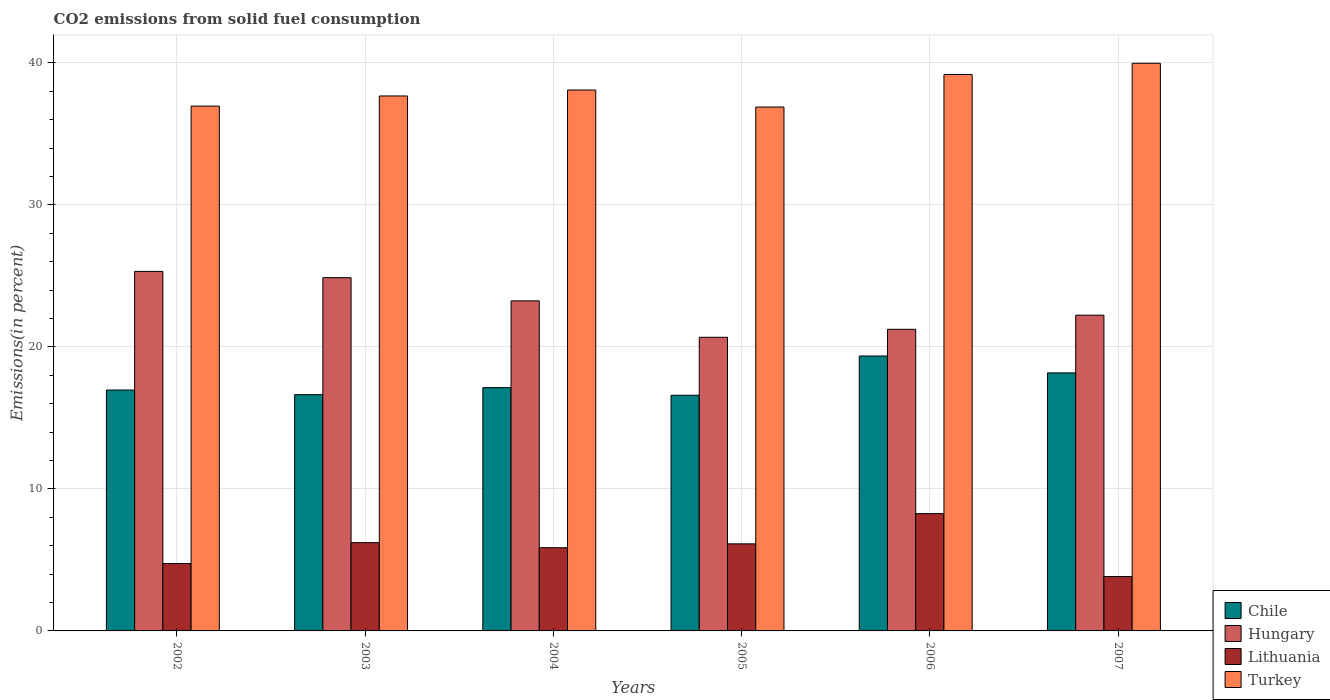How many different coloured bars are there?
Offer a very short reply. 4. Are the number of bars on each tick of the X-axis equal?
Offer a terse response. Yes. How many bars are there on the 3rd tick from the right?
Offer a terse response. 4. What is the label of the 2nd group of bars from the left?
Give a very brief answer. 2003. What is the total CO2 emitted in Lithuania in 2007?
Your response must be concise. 3.83. Across all years, what is the maximum total CO2 emitted in Chile?
Your response must be concise. 19.36. Across all years, what is the minimum total CO2 emitted in Turkey?
Your answer should be very brief. 36.9. In which year was the total CO2 emitted in Chile maximum?
Provide a short and direct response. 2006. What is the total total CO2 emitted in Lithuania in the graph?
Make the answer very short. 35.05. What is the difference between the total CO2 emitted in Turkey in 2003 and that in 2007?
Offer a terse response. -2.3. What is the difference between the total CO2 emitted in Lithuania in 2005 and the total CO2 emitted in Hungary in 2006?
Ensure brevity in your answer.  -15.11. What is the average total CO2 emitted in Hungary per year?
Give a very brief answer. 22.93. In the year 2003, what is the difference between the total CO2 emitted in Lithuania and total CO2 emitted in Turkey?
Keep it short and to the point. -31.46. In how many years, is the total CO2 emitted in Lithuania greater than 38 %?
Your answer should be compact. 0. What is the ratio of the total CO2 emitted in Lithuania in 2003 to that in 2004?
Offer a very short reply. 1.06. Is the difference between the total CO2 emitted in Lithuania in 2003 and 2007 greater than the difference between the total CO2 emitted in Turkey in 2003 and 2007?
Your answer should be very brief. Yes. What is the difference between the highest and the second highest total CO2 emitted in Turkey?
Offer a very short reply. 0.79. What is the difference between the highest and the lowest total CO2 emitted in Turkey?
Your answer should be compact. 3.08. What does the 2nd bar from the left in 2005 represents?
Ensure brevity in your answer.  Hungary. Are all the bars in the graph horizontal?
Ensure brevity in your answer.  No. How many years are there in the graph?
Your answer should be compact. 6. Are the values on the major ticks of Y-axis written in scientific E-notation?
Give a very brief answer. No. Does the graph contain grids?
Ensure brevity in your answer.  Yes. Where does the legend appear in the graph?
Your response must be concise. Bottom right. How are the legend labels stacked?
Provide a succinct answer. Vertical. What is the title of the graph?
Your answer should be very brief. CO2 emissions from solid fuel consumption. What is the label or title of the X-axis?
Keep it short and to the point. Years. What is the label or title of the Y-axis?
Offer a terse response. Emissions(in percent). What is the Emissions(in percent) of Chile in 2002?
Offer a very short reply. 16.96. What is the Emissions(in percent) in Hungary in 2002?
Keep it short and to the point. 25.32. What is the Emissions(in percent) of Lithuania in 2002?
Make the answer very short. 4.75. What is the Emissions(in percent) of Turkey in 2002?
Ensure brevity in your answer.  36.96. What is the Emissions(in percent) of Chile in 2003?
Give a very brief answer. 16.64. What is the Emissions(in percent) in Hungary in 2003?
Your answer should be compact. 24.88. What is the Emissions(in percent) of Lithuania in 2003?
Provide a succinct answer. 6.22. What is the Emissions(in percent) in Turkey in 2003?
Keep it short and to the point. 37.67. What is the Emissions(in percent) in Chile in 2004?
Offer a terse response. 17.13. What is the Emissions(in percent) of Hungary in 2004?
Ensure brevity in your answer.  23.24. What is the Emissions(in percent) in Lithuania in 2004?
Offer a terse response. 5.86. What is the Emissions(in percent) in Turkey in 2004?
Give a very brief answer. 38.09. What is the Emissions(in percent) of Chile in 2005?
Your response must be concise. 16.6. What is the Emissions(in percent) of Hungary in 2005?
Give a very brief answer. 20.68. What is the Emissions(in percent) of Lithuania in 2005?
Ensure brevity in your answer.  6.13. What is the Emissions(in percent) of Turkey in 2005?
Ensure brevity in your answer.  36.9. What is the Emissions(in percent) of Chile in 2006?
Provide a short and direct response. 19.36. What is the Emissions(in percent) of Hungary in 2006?
Your answer should be compact. 21.24. What is the Emissions(in percent) of Lithuania in 2006?
Provide a short and direct response. 8.26. What is the Emissions(in percent) of Turkey in 2006?
Your response must be concise. 39.19. What is the Emissions(in percent) of Chile in 2007?
Your answer should be very brief. 18.17. What is the Emissions(in percent) of Hungary in 2007?
Provide a succinct answer. 22.24. What is the Emissions(in percent) in Lithuania in 2007?
Offer a very short reply. 3.83. What is the Emissions(in percent) of Turkey in 2007?
Make the answer very short. 39.98. Across all years, what is the maximum Emissions(in percent) in Chile?
Your answer should be compact. 19.36. Across all years, what is the maximum Emissions(in percent) in Hungary?
Your answer should be very brief. 25.32. Across all years, what is the maximum Emissions(in percent) of Lithuania?
Your answer should be very brief. 8.26. Across all years, what is the maximum Emissions(in percent) of Turkey?
Give a very brief answer. 39.98. Across all years, what is the minimum Emissions(in percent) in Chile?
Offer a terse response. 16.6. Across all years, what is the minimum Emissions(in percent) of Hungary?
Make the answer very short. 20.68. Across all years, what is the minimum Emissions(in percent) of Lithuania?
Your answer should be very brief. 3.83. Across all years, what is the minimum Emissions(in percent) of Turkey?
Your answer should be very brief. 36.9. What is the total Emissions(in percent) in Chile in the graph?
Make the answer very short. 104.87. What is the total Emissions(in percent) in Hungary in the graph?
Give a very brief answer. 137.6. What is the total Emissions(in percent) of Lithuania in the graph?
Provide a succinct answer. 35.05. What is the total Emissions(in percent) in Turkey in the graph?
Your response must be concise. 228.79. What is the difference between the Emissions(in percent) in Chile in 2002 and that in 2003?
Your response must be concise. 0.33. What is the difference between the Emissions(in percent) in Hungary in 2002 and that in 2003?
Make the answer very short. 0.44. What is the difference between the Emissions(in percent) of Lithuania in 2002 and that in 2003?
Your response must be concise. -1.47. What is the difference between the Emissions(in percent) of Turkey in 2002 and that in 2003?
Provide a short and direct response. -0.71. What is the difference between the Emissions(in percent) in Chile in 2002 and that in 2004?
Give a very brief answer. -0.17. What is the difference between the Emissions(in percent) in Hungary in 2002 and that in 2004?
Give a very brief answer. 2.08. What is the difference between the Emissions(in percent) in Lithuania in 2002 and that in 2004?
Give a very brief answer. -1.11. What is the difference between the Emissions(in percent) of Turkey in 2002 and that in 2004?
Ensure brevity in your answer.  -1.13. What is the difference between the Emissions(in percent) in Chile in 2002 and that in 2005?
Your answer should be very brief. 0.37. What is the difference between the Emissions(in percent) of Hungary in 2002 and that in 2005?
Make the answer very short. 4.64. What is the difference between the Emissions(in percent) of Lithuania in 2002 and that in 2005?
Give a very brief answer. -1.39. What is the difference between the Emissions(in percent) in Turkey in 2002 and that in 2005?
Keep it short and to the point. 0.07. What is the difference between the Emissions(in percent) in Chile in 2002 and that in 2006?
Keep it short and to the point. -2.4. What is the difference between the Emissions(in percent) in Hungary in 2002 and that in 2006?
Your answer should be compact. 4.08. What is the difference between the Emissions(in percent) of Lithuania in 2002 and that in 2006?
Keep it short and to the point. -3.51. What is the difference between the Emissions(in percent) of Turkey in 2002 and that in 2006?
Offer a terse response. -2.23. What is the difference between the Emissions(in percent) of Chile in 2002 and that in 2007?
Provide a short and direct response. -1.21. What is the difference between the Emissions(in percent) in Hungary in 2002 and that in 2007?
Your response must be concise. 3.08. What is the difference between the Emissions(in percent) in Lithuania in 2002 and that in 2007?
Keep it short and to the point. 0.92. What is the difference between the Emissions(in percent) of Turkey in 2002 and that in 2007?
Ensure brevity in your answer.  -3.02. What is the difference between the Emissions(in percent) of Chile in 2003 and that in 2004?
Ensure brevity in your answer.  -0.49. What is the difference between the Emissions(in percent) of Hungary in 2003 and that in 2004?
Offer a very short reply. 1.63. What is the difference between the Emissions(in percent) in Lithuania in 2003 and that in 2004?
Your answer should be compact. 0.36. What is the difference between the Emissions(in percent) of Turkey in 2003 and that in 2004?
Give a very brief answer. -0.42. What is the difference between the Emissions(in percent) in Chile in 2003 and that in 2005?
Offer a very short reply. 0.04. What is the difference between the Emissions(in percent) of Hungary in 2003 and that in 2005?
Give a very brief answer. 4.2. What is the difference between the Emissions(in percent) in Lithuania in 2003 and that in 2005?
Make the answer very short. 0.09. What is the difference between the Emissions(in percent) in Turkey in 2003 and that in 2005?
Your response must be concise. 0.78. What is the difference between the Emissions(in percent) in Chile in 2003 and that in 2006?
Make the answer very short. -2.72. What is the difference between the Emissions(in percent) in Hungary in 2003 and that in 2006?
Provide a succinct answer. 3.64. What is the difference between the Emissions(in percent) in Lithuania in 2003 and that in 2006?
Give a very brief answer. -2.04. What is the difference between the Emissions(in percent) in Turkey in 2003 and that in 2006?
Your response must be concise. -1.51. What is the difference between the Emissions(in percent) in Chile in 2003 and that in 2007?
Offer a terse response. -1.53. What is the difference between the Emissions(in percent) in Hungary in 2003 and that in 2007?
Your answer should be compact. 2.64. What is the difference between the Emissions(in percent) in Lithuania in 2003 and that in 2007?
Make the answer very short. 2.39. What is the difference between the Emissions(in percent) in Turkey in 2003 and that in 2007?
Your response must be concise. -2.3. What is the difference between the Emissions(in percent) of Chile in 2004 and that in 2005?
Ensure brevity in your answer.  0.54. What is the difference between the Emissions(in percent) in Hungary in 2004 and that in 2005?
Provide a succinct answer. 2.56. What is the difference between the Emissions(in percent) in Lithuania in 2004 and that in 2005?
Your answer should be very brief. -0.27. What is the difference between the Emissions(in percent) in Turkey in 2004 and that in 2005?
Ensure brevity in your answer.  1.2. What is the difference between the Emissions(in percent) of Chile in 2004 and that in 2006?
Ensure brevity in your answer.  -2.23. What is the difference between the Emissions(in percent) in Hungary in 2004 and that in 2006?
Your answer should be very brief. 2. What is the difference between the Emissions(in percent) in Lithuania in 2004 and that in 2006?
Ensure brevity in your answer.  -2.4. What is the difference between the Emissions(in percent) in Turkey in 2004 and that in 2006?
Your answer should be very brief. -1.09. What is the difference between the Emissions(in percent) in Chile in 2004 and that in 2007?
Offer a very short reply. -1.04. What is the difference between the Emissions(in percent) in Hungary in 2004 and that in 2007?
Offer a very short reply. 1.01. What is the difference between the Emissions(in percent) in Lithuania in 2004 and that in 2007?
Offer a very short reply. 2.03. What is the difference between the Emissions(in percent) in Turkey in 2004 and that in 2007?
Your answer should be very brief. -1.88. What is the difference between the Emissions(in percent) of Chile in 2005 and that in 2006?
Keep it short and to the point. -2.76. What is the difference between the Emissions(in percent) of Hungary in 2005 and that in 2006?
Your answer should be compact. -0.56. What is the difference between the Emissions(in percent) of Lithuania in 2005 and that in 2006?
Your answer should be very brief. -2.13. What is the difference between the Emissions(in percent) in Turkey in 2005 and that in 2006?
Make the answer very short. -2.29. What is the difference between the Emissions(in percent) in Chile in 2005 and that in 2007?
Provide a short and direct response. -1.57. What is the difference between the Emissions(in percent) in Hungary in 2005 and that in 2007?
Offer a terse response. -1.56. What is the difference between the Emissions(in percent) of Lithuania in 2005 and that in 2007?
Your answer should be compact. 2.3. What is the difference between the Emissions(in percent) in Turkey in 2005 and that in 2007?
Your answer should be very brief. -3.08. What is the difference between the Emissions(in percent) of Chile in 2006 and that in 2007?
Keep it short and to the point. 1.19. What is the difference between the Emissions(in percent) of Hungary in 2006 and that in 2007?
Provide a succinct answer. -1. What is the difference between the Emissions(in percent) of Lithuania in 2006 and that in 2007?
Provide a succinct answer. 4.43. What is the difference between the Emissions(in percent) of Turkey in 2006 and that in 2007?
Your answer should be very brief. -0.79. What is the difference between the Emissions(in percent) of Chile in 2002 and the Emissions(in percent) of Hungary in 2003?
Provide a succinct answer. -7.91. What is the difference between the Emissions(in percent) of Chile in 2002 and the Emissions(in percent) of Lithuania in 2003?
Make the answer very short. 10.75. What is the difference between the Emissions(in percent) of Chile in 2002 and the Emissions(in percent) of Turkey in 2003?
Offer a very short reply. -20.71. What is the difference between the Emissions(in percent) of Hungary in 2002 and the Emissions(in percent) of Lithuania in 2003?
Keep it short and to the point. 19.1. What is the difference between the Emissions(in percent) of Hungary in 2002 and the Emissions(in percent) of Turkey in 2003?
Provide a short and direct response. -12.36. What is the difference between the Emissions(in percent) of Lithuania in 2002 and the Emissions(in percent) of Turkey in 2003?
Ensure brevity in your answer.  -32.93. What is the difference between the Emissions(in percent) of Chile in 2002 and the Emissions(in percent) of Hungary in 2004?
Provide a short and direct response. -6.28. What is the difference between the Emissions(in percent) of Chile in 2002 and the Emissions(in percent) of Lithuania in 2004?
Your answer should be compact. 11.11. What is the difference between the Emissions(in percent) of Chile in 2002 and the Emissions(in percent) of Turkey in 2004?
Your answer should be very brief. -21.13. What is the difference between the Emissions(in percent) in Hungary in 2002 and the Emissions(in percent) in Lithuania in 2004?
Provide a short and direct response. 19.46. What is the difference between the Emissions(in percent) in Hungary in 2002 and the Emissions(in percent) in Turkey in 2004?
Your answer should be compact. -12.77. What is the difference between the Emissions(in percent) of Lithuania in 2002 and the Emissions(in percent) of Turkey in 2004?
Offer a very short reply. -33.35. What is the difference between the Emissions(in percent) of Chile in 2002 and the Emissions(in percent) of Hungary in 2005?
Your response must be concise. -3.72. What is the difference between the Emissions(in percent) in Chile in 2002 and the Emissions(in percent) in Lithuania in 2005?
Provide a short and direct response. 10.83. What is the difference between the Emissions(in percent) in Chile in 2002 and the Emissions(in percent) in Turkey in 2005?
Offer a very short reply. -19.93. What is the difference between the Emissions(in percent) of Hungary in 2002 and the Emissions(in percent) of Lithuania in 2005?
Your answer should be very brief. 19.19. What is the difference between the Emissions(in percent) in Hungary in 2002 and the Emissions(in percent) in Turkey in 2005?
Give a very brief answer. -11.58. What is the difference between the Emissions(in percent) in Lithuania in 2002 and the Emissions(in percent) in Turkey in 2005?
Your answer should be very brief. -32.15. What is the difference between the Emissions(in percent) of Chile in 2002 and the Emissions(in percent) of Hungary in 2006?
Ensure brevity in your answer.  -4.27. What is the difference between the Emissions(in percent) in Chile in 2002 and the Emissions(in percent) in Lithuania in 2006?
Provide a succinct answer. 8.7. What is the difference between the Emissions(in percent) in Chile in 2002 and the Emissions(in percent) in Turkey in 2006?
Your answer should be very brief. -22.22. What is the difference between the Emissions(in percent) in Hungary in 2002 and the Emissions(in percent) in Lithuania in 2006?
Offer a very short reply. 17.06. What is the difference between the Emissions(in percent) of Hungary in 2002 and the Emissions(in percent) of Turkey in 2006?
Offer a very short reply. -13.87. What is the difference between the Emissions(in percent) of Lithuania in 2002 and the Emissions(in percent) of Turkey in 2006?
Make the answer very short. -34.44. What is the difference between the Emissions(in percent) in Chile in 2002 and the Emissions(in percent) in Hungary in 2007?
Provide a short and direct response. -5.27. What is the difference between the Emissions(in percent) in Chile in 2002 and the Emissions(in percent) in Lithuania in 2007?
Offer a terse response. 13.14. What is the difference between the Emissions(in percent) in Chile in 2002 and the Emissions(in percent) in Turkey in 2007?
Your answer should be very brief. -23.01. What is the difference between the Emissions(in percent) in Hungary in 2002 and the Emissions(in percent) in Lithuania in 2007?
Ensure brevity in your answer.  21.49. What is the difference between the Emissions(in percent) in Hungary in 2002 and the Emissions(in percent) in Turkey in 2007?
Provide a succinct answer. -14.66. What is the difference between the Emissions(in percent) in Lithuania in 2002 and the Emissions(in percent) in Turkey in 2007?
Provide a succinct answer. -35.23. What is the difference between the Emissions(in percent) of Chile in 2003 and the Emissions(in percent) of Hungary in 2004?
Provide a succinct answer. -6.6. What is the difference between the Emissions(in percent) in Chile in 2003 and the Emissions(in percent) in Lithuania in 2004?
Provide a short and direct response. 10.78. What is the difference between the Emissions(in percent) in Chile in 2003 and the Emissions(in percent) in Turkey in 2004?
Provide a succinct answer. -21.45. What is the difference between the Emissions(in percent) of Hungary in 2003 and the Emissions(in percent) of Lithuania in 2004?
Make the answer very short. 19.02. What is the difference between the Emissions(in percent) of Hungary in 2003 and the Emissions(in percent) of Turkey in 2004?
Make the answer very short. -13.22. What is the difference between the Emissions(in percent) of Lithuania in 2003 and the Emissions(in percent) of Turkey in 2004?
Keep it short and to the point. -31.88. What is the difference between the Emissions(in percent) in Chile in 2003 and the Emissions(in percent) in Hungary in 2005?
Make the answer very short. -4.04. What is the difference between the Emissions(in percent) of Chile in 2003 and the Emissions(in percent) of Lithuania in 2005?
Your response must be concise. 10.51. What is the difference between the Emissions(in percent) of Chile in 2003 and the Emissions(in percent) of Turkey in 2005?
Offer a terse response. -20.26. What is the difference between the Emissions(in percent) in Hungary in 2003 and the Emissions(in percent) in Lithuania in 2005?
Offer a very short reply. 18.75. What is the difference between the Emissions(in percent) in Hungary in 2003 and the Emissions(in percent) in Turkey in 2005?
Your answer should be compact. -12.02. What is the difference between the Emissions(in percent) in Lithuania in 2003 and the Emissions(in percent) in Turkey in 2005?
Give a very brief answer. -30.68. What is the difference between the Emissions(in percent) in Chile in 2003 and the Emissions(in percent) in Hungary in 2006?
Give a very brief answer. -4.6. What is the difference between the Emissions(in percent) in Chile in 2003 and the Emissions(in percent) in Lithuania in 2006?
Give a very brief answer. 8.38. What is the difference between the Emissions(in percent) in Chile in 2003 and the Emissions(in percent) in Turkey in 2006?
Ensure brevity in your answer.  -22.55. What is the difference between the Emissions(in percent) of Hungary in 2003 and the Emissions(in percent) of Lithuania in 2006?
Provide a succinct answer. 16.62. What is the difference between the Emissions(in percent) in Hungary in 2003 and the Emissions(in percent) in Turkey in 2006?
Your answer should be very brief. -14.31. What is the difference between the Emissions(in percent) of Lithuania in 2003 and the Emissions(in percent) of Turkey in 2006?
Your answer should be very brief. -32.97. What is the difference between the Emissions(in percent) in Chile in 2003 and the Emissions(in percent) in Hungary in 2007?
Offer a very short reply. -5.6. What is the difference between the Emissions(in percent) of Chile in 2003 and the Emissions(in percent) of Lithuania in 2007?
Provide a succinct answer. 12.81. What is the difference between the Emissions(in percent) in Chile in 2003 and the Emissions(in percent) in Turkey in 2007?
Offer a terse response. -23.34. What is the difference between the Emissions(in percent) in Hungary in 2003 and the Emissions(in percent) in Lithuania in 2007?
Keep it short and to the point. 21.05. What is the difference between the Emissions(in percent) of Hungary in 2003 and the Emissions(in percent) of Turkey in 2007?
Ensure brevity in your answer.  -15.1. What is the difference between the Emissions(in percent) in Lithuania in 2003 and the Emissions(in percent) in Turkey in 2007?
Your answer should be compact. -33.76. What is the difference between the Emissions(in percent) of Chile in 2004 and the Emissions(in percent) of Hungary in 2005?
Give a very brief answer. -3.55. What is the difference between the Emissions(in percent) in Chile in 2004 and the Emissions(in percent) in Lithuania in 2005?
Offer a very short reply. 11. What is the difference between the Emissions(in percent) of Chile in 2004 and the Emissions(in percent) of Turkey in 2005?
Keep it short and to the point. -19.76. What is the difference between the Emissions(in percent) in Hungary in 2004 and the Emissions(in percent) in Lithuania in 2005?
Offer a very short reply. 17.11. What is the difference between the Emissions(in percent) of Hungary in 2004 and the Emissions(in percent) of Turkey in 2005?
Make the answer very short. -13.65. What is the difference between the Emissions(in percent) in Lithuania in 2004 and the Emissions(in percent) in Turkey in 2005?
Ensure brevity in your answer.  -31.04. What is the difference between the Emissions(in percent) in Chile in 2004 and the Emissions(in percent) in Hungary in 2006?
Your response must be concise. -4.11. What is the difference between the Emissions(in percent) in Chile in 2004 and the Emissions(in percent) in Lithuania in 2006?
Your response must be concise. 8.87. What is the difference between the Emissions(in percent) of Chile in 2004 and the Emissions(in percent) of Turkey in 2006?
Give a very brief answer. -22.05. What is the difference between the Emissions(in percent) of Hungary in 2004 and the Emissions(in percent) of Lithuania in 2006?
Keep it short and to the point. 14.98. What is the difference between the Emissions(in percent) of Hungary in 2004 and the Emissions(in percent) of Turkey in 2006?
Make the answer very short. -15.94. What is the difference between the Emissions(in percent) of Lithuania in 2004 and the Emissions(in percent) of Turkey in 2006?
Your response must be concise. -33.33. What is the difference between the Emissions(in percent) in Chile in 2004 and the Emissions(in percent) in Hungary in 2007?
Offer a terse response. -5.1. What is the difference between the Emissions(in percent) in Chile in 2004 and the Emissions(in percent) in Lithuania in 2007?
Keep it short and to the point. 13.3. What is the difference between the Emissions(in percent) of Chile in 2004 and the Emissions(in percent) of Turkey in 2007?
Make the answer very short. -22.84. What is the difference between the Emissions(in percent) of Hungary in 2004 and the Emissions(in percent) of Lithuania in 2007?
Your answer should be compact. 19.41. What is the difference between the Emissions(in percent) in Hungary in 2004 and the Emissions(in percent) in Turkey in 2007?
Ensure brevity in your answer.  -16.73. What is the difference between the Emissions(in percent) of Lithuania in 2004 and the Emissions(in percent) of Turkey in 2007?
Your answer should be very brief. -34.12. What is the difference between the Emissions(in percent) of Chile in 2005 and the Emissions(in percent) of Hungary in 2006?
Give a very brief answer. -4.64. What is the difference between the Emissions(in percent) of Chile in 2005 and the Emissions(in percent) of Lithuania in 2006?
Offer a very short reply. 8.34. What is the difference between the Emissions(in percent) in Chile in 2005 and the Emissions(in percent) in Turkey in 2006?
Your answer should be very brief. -22.59. What is the difference between the Emissions(in percent) in Hungary in 2005 and the Emissions(in percent) in Lithuania in 2006?
Make the answer very short. 12.42. What is the difference between the Emissions(in percent) in Hungary in 2005 and the Emissions(in percent) in Turkey in 2006?
Keep it short and to the point. -18.51. What is the difference between the Emissions(in percent) of Lithuania in 2005 and the Emissions(in percent) of Turkey in 2006?
Offer a terse response. -33.05. What is the difference between the Emissions(in percent) of Chile in 2005 and the Emissions(in percent) of Hungary in 2007?
Offer a very short reply. -5.64. What is the difference between the Emissions(in percent) in Chile in 2005 and the Emissions(in percent) in Lithuania in 2007?
Keep it short and to the point. 12.77. What is the difference between the Emissions(in percent) of Chile in 2005 and the Emissions(in percent) of Turkey in 2007?
Offer a terse response. -23.38. What is the difference between the Emissions(in percent) of Hungary in 2005 and the Emissions(in percent) of Lithuania in 2007?
Offer a terse response. 16.85. What is the difference between the Emissions(in percent) in Hungary in 2005 and the Emissions(in percent) in Turkey in 2007?
Provide a succinct answer. -19.3. What is the difference between the Emissions(in percent) of Lithuania in 2005 and the Emissions(in percent) of Turkey in 2007?
Offer a very short reply. -33.84. What is the difference between the Emissions(in percent) in Chile in 2006 and the Emissions(in percent) in Hungary in 2007?
Give a very brief answer. -2.88. What is the difference between the Emissions(in percent) in Chile in 2006 and the Emissions(in percent) in Lithuania in 2007?
Make the answer very short. 15.53. What is the difference between the Emissions(in percent) in Chile in 2006 and the Emissions(in percent) in Turkey in 2007?
Make the answer very short. -20.62. What is the difference between the Emissions(in percent) in Hungary in 2006 and the Emissions(in percent) in Lithuania in 2007?
Provide a short and direct response. 17.41. What is the difference between the Emissions(in percent) in Hungary in 2006 and the Emissions(in percent) in Turkey in 2007?
Your response must be concise. -18.74. What is the difference between the Emissions(in percent) in Lithuania in 2006 and the Emissions(in percent) in Turkey in 2007?
Keep it short and to the point. -31.72. What is the average Emissions(in percent) of Chile per year?
Offer a very short reply. 17.48. What is the average Emissions(in percent) of Hungary per year?
Provide a short and direct response. 22.93. What is the average Emissions(in percent) of Lithuania per year?
Offer a terse response. 5.84. What is the average Emissions(in percent) in Turkey per year?
Offer a very short reply. 38.13. In the year 2002, what is the difference between the Emissions(in percent) in Chile and Emissions(in percent) in Hungary?
Offer a terse response. -8.35. In the year 2002, what is the difference between the Emissions(in percent) in Chile and Emissions(in percent) in Lithuania?
Offer a terse response. 12.22. In the year 2002, what is the difference between the Emissions(in percent) in Chile and Emissions(in percent) in Turkey?
Make the answer very short. -20. In the year 2002, what is the difference between the Emissions(in percent) in Hungary and Emissions(in percent) in Lithuania?
Make the answer very short. 20.57. In the year 2002, what is the difference between the Emissions(in percent) of Hungary and Emissions(in percent) of Turkey?
Provide a short and direct response. -11.64. In the year 2002, what is the difference between the Emissions(in percent) of Lithuania and Emissions(in percent) of Turkey?
Your response must be concise. -32.22. In the year 2003, what is the difference between the Emissions(in percent) in Chile and Emissions(in percent) in Hungary?
Ensure brevity in your answer.  -8.24. In the year 2003, what is the difference between the Emissions(in percent) of Chile and Emissions(in percent) of Lithuania?
Your answer should be compact. 10.42. In the year 2003, what is the difference between the Emissions(in percent) of Chile and Emissions(in percent) of Turkey?
Ensure brevity in your answer.  -21.04. In the year 2003, what is the difference between the Emissions(in percent) of Hungary and Emissions(in percent) of Lithuania?
Your answer should be compact. 18.66. In the year 2003, what is the difference between the Emissions(in percent) of Hungary and Emissions(in percent) of Turkey?
Make the answer very short. -12.8. In the year 2003, what is the difference between the Emissions(in percent) of Lithuania and Emissions(in percent) of Turkey?
Provide a succinct answer. -31.46. In the year 2004, what is the difference between the Emissions(in percent) of Chile and Emissions(in percent) of Hungary?
Offer a very short reply. -6.11. In the year 2004, what is the difference between the Emissions(in percent) in Chile and Emissions(in percent) in Lithuania?
Your answer should be very brief. 11.27. In the year 2004, what is the difference between the Emissions(in percent) of Chile and Emissions(in percent) of Turkey?
Offer a terse response. -20.96. In the year 2004, what is the difference between the Emissions(in percent) in Hungary and Emissions(in percent) in Lithuania?
Ensure brevity in your answer.  17.38. In the year 2004, what is the difference between the Emissions(in percent) in Hungary and Emissions(in percent) in Turkey?
Provide a succinct answer. -14.85. In the year 2004, what is the difference between the Emissions(in percent) of Lithuania and Emissions(in percent) of Turkey?
Provide a short and direct response. -32.23. In the year 2005, what is the difference between the Emissions(in percent) in Chile and Emissions(in percent) in Hungary?
Provide a short and direct response. -4.08. In the year 2005, what is the difference between the Emissions(in percent) of Chile and Emissions(in percent) of Lithuania?
Keep it short and to the point. 10.47. In the year 2005, what is the difference between the Emissions(in percent) of Chile and Emissions(in percent) of Turkey?
Provide a succinct answer. -20.3. In the year 2005, what is the difference between the Emissions(in percent) in Hungary and Emissions(in percent) in Lithuania?
Your response must be concise. 14.55. In the year 2005, what is the difference between the Emissions(in percent) in Hungary and Emissions(in percent) in Turkey?
Your response must be concise. -16.22. In the year 2005, what is the difference between the Emissions(in percent) of Lithuania and Emissions(in percent) of Turkey?
Give a very brief answer. -30.76. In the year 2006, what is the difference between the Emissions(in percent) of Chile and Emissions(in percent) of Hungary?
Give a very brief answer. -1.88. In the year 2006, what is the difference between the Emissions(in percent) in Chile and Emissions(in percent) in Turkey?
Keep it short and to the point. -19.83. In the year 2006, what is the difference between the Emissions(in percent) in Hungary and Emissions(in percent) in Lithuania?
Give a very brief answer. 12.98. In the year 2006, what is the difference between the Emissions(in percent) of Hungary and Emissions(in percent) of Turkey?
Your answer should be very brief. -17.95. In the year 2006, what is the difference between the Emissions(in percent) of Lithuania and Emissions(in percent) of Turkey?
Make the answer very short. -30.93. In the year 2007, what is the difference between the Emissions(in percent) in Chile and Emissions(in percent) in Hungary?
Your answer should be very brief. -4.07. In the year 2007, what is the difference between the Emissions(in percent) in Chile and Emissions(in percent) in Lithuania?
Offer a very short reply. 14.34. In the year 2007, what is the difference between the Emissions(in percent) of Chile and Emissions(in percent) of Turkey?
Offer a terse response. -21.81. In the year 2007, what is the difference between the Emissions(in percent) in Hungary and Emissions(in percent) in Lithuania?
Keep it short and to the point. 18.41. In the year 2007, what is the difference between the Emissions(in percent) of Hungary and Emissions(in percent) of Turkey?
Ensure brevity in your answer.  -17.74. In the year 2007, what is the difference between the Emissions(in percent) of Lithuania and Emissions(in percent) of Turkey?
Your answer should be compact. -36.15. What is the ratio of the Emissions(in percent) in Chile in 2002 to that in 2003?
Your response must be concise. 1.02. What is the ratio of the Emissions(in percent) in Hungary in 2002 to that in 2003?
Your answer should be very brief. 1.02. What is the ratio of the Emissions(in percent) in Lithuania in 2002 to that in 2003?
Your answer should be compact. 0.76. What is the ratio of the Emissions(in percent) in Turkey in 2002 to that in 2003?
Your response must be concise. 0.98. What is the ratio of the Emissions(in percent) of Chile in 2002 to that in 2004?
Ensure brevity in your answer.  0.99. What is the ratio of the Emissions(in percent) in Hungary in 2002 to that in 2004?
Your answer should be compact. 1.09. What is the ratio of the Emissions(in percent) in Lithuania in 2002 to that in 2004?
Your answer should be compact. 0.81. What is the ratio of the Emissions(in percent) in Turkey in 2002 to that in 2004?
Offer a terse response. 0.97. What is the ratio of the Emissions(in percent) of Chile in 2002 to that in 2005?
Provide a succinct answer. 1.02. What is the ratio of the Emissions(in percent) in Hungary in 2002 to that in 2005?
Keep it short and to the point. 1.22. What is the ratio of the Emissions(in percent) of Lithuania in 2002 to that in 2005?
Your answer should be very brief. 0.77. What is the ratio of the Emissions(in percent) of Turkey in 2002 to that in 2005?
Provide a short and direct response. 1. What is the ratio of the Emissions(in percent) of Chile in 2002 to that in 2006?
Give a very brief answer. 0.88. What is the ratio of the Emissions(in percent) in Hungary in 2002 to that in 2006?
Provide a succinct answer. 1.19. What is the ratio of the Emissions(in percent) in Lithuania in 2002 to that in 2006?
Your answer should be compact. 0.57. What is the ratio of the Emissions(in percent) in Turkey in 2002 to that in 2006?
Your answer should be very brief. 0.94. What is the ratio of the Emissions(in percent) in Chile in 2002 to that in 2007?
Provide a short and direct response. 0.93. What is the ratio of the Emissions(in percent) in Hungary in 2002 to that in 2007?
Provide a short and direct response. 1.14. What is the ratio of the Emissions(in percent) in Lithuania in 2002 to that in 2007?
Offer a terse response. 1.24. What is the ratio of the Emissions(in percent) of Turkey in 2002 to that in 2007?
Ensure brevity in your answer.  0.92. What is the ratio of the Emissions(in percent) in Chile in 2003 to that in 2004?
Keep it short and to the point. 0.97. What is the ratio of the Emissions(in percent) of Hungary in 2003 to that in 2004?
Provide a succinct answer. 1.07. What is the ratio of the Emissions(in percent) of Lithuania in 2003 to that in 2004?
Your response must be concise. 1.06. What is the ratio of the Emissions(in percent) of Turkey in 2003 to that in 2004?
Make the answer very short. 0.99. What is the ratio of the Emissions(in percent) in Chile in 2003 to that in 2005?
Provide a short and direct response. 1. What is the ratio of the Emissions(in percent) of Hungary in 2003 to that in 2005?
Keep it short and to the point. 1.2. What is the ratio of the Emissions(in percent) of Turkey in 2003 to that in 2005?
Offer a very short reply. 1.02. What is the ratio of the Emissions(in percent) in Chile in 2003 to that in 2006?
Ensure brevity in your answer.  0.86. What is the ratio of the Emissions(in percent) of Hungary in 2003 to that in 2006?
Provide a short and direct response. 1.17. What is the ratio of the Emissions(in percent) of Lithuania in 2003 to that in 2006?
Offer a terse response. 0.75. What is the ratio of the Emissions(in percent) of Turkey in 2003 to that in 2006?
Your answer should be compact. 0.96. What is the ratio of the Emissions(in percent) of Chile in 2003 to that in 2007?
Offer a terse response. 0.92. What is the ratio of the Emissions(in percent) in Hungary in 2003 to that in 2007?
Your answer should be compact. 1.12. What is the ratio of the Emissions(in percent) in Lithuania in 2003 to that in 2007?
Offer a very short reply. 1.62. What is the ratio of the Emissions(in percent) in Turkey in 2003 to that in 2007?
Offer a very short reply. 0.94. What is the ratio of the Emissions(in percent) in Chile in 2004 to that in 2005?
Provide a short and direct response. 1.03. What is the ratio of the Emissions(in percent) in Hungary in 2004 to that in 2005?
Offer a terse response. 1.12. What is the ratio of the Emissions(in percent) of Lithuania in 2004 to that in 2005?
Your answer should be compact. 0.96. What is the ratio of the Emissions(in percent) in Turkey in 2004 to that in 2005?
Your answer should be compact. 1.03. What is the ratio of the Emissions(in percent) of Chile in 2004 to that in 2006?
Offer a very short reply. 0.89. What is the ratio of the Emissions(in percent) in Hungary in 2004 to that in 2006?
Provide a short and direct response. 1.09. What is the ratio of the Emissions(in percent) in Lithuania in 2004 to that in 2006?
Your answer should be compact. 0.71. What is the ratio of the Emissions(in percent) of Turkey in 2004 to that in 2006?
Give a very brief answer. 0.97. What is the ratio of the Emissions(in percent) of Chile in 2004 to that in 2007?
Give a very brief answer. 0.94. What is the ratio of the Emissions(in percent) in Hungary in 2004 to that in 2007?
Make the answer very short. 1.05. What is the ratio of the Emissions(in percent) in Lithuania in 2004 to that in 2007?
Your answer should be very brief. 1.53. What is the ratio of the Emissions(in percent) of Turkey in 2004 to that in 2007?
Your response must be concise. 0.95. What is the ratio of the Emissions(in percent) in Chile in 2005 to that in 2006?
Provide a succinct answer. 0.86. What is the ratio of the Emissions(in percent) of Hungary in 2005 to that in 2006?
Your answer should be compact. 0.97. What is the ratio of the Emissions(in percent) of Lithuania in 2005 to that in 2006?
Offer a very short reply. 0.74. What is the ratio of the Emissions(in percent) of Turkey in 2005 to that in 2006?
Provide a succinct answer. 0.94. What is the ratio of the Emissions(in percent) in Chile in 2005 to that in 2007?
Ensure brevity in your answer.  0.91. What is the ratio of the Emissions(in percent) of Hungary in 2005 to that in 2007?
Your answer should be compact. 0.93. What is the ratio of the Emissions(in percent) of Lithuania in 2005 to that in 2007?
Provide a succinct answer. 1.6. What is the ratio of the Emissions(in percent) of Turkey in 2005 to that in 2007?
Your answer should be compact. 0.92. What is the ratio of the Emissions(in percent) of Chile in 2006 to that in 2007?
Your answer should be compact. 1.07. What is the ratio of the Emissions(in percent) in Hungary in 2006 to that in 2007?
Give a very brief answer. 0.96. What is the ratio of the Emissions(in percent) in Lithuania in 2006 to that in 2007?
Keep it short and to the point. 2.16. What is the ratio of the Emissions(in percent) in Turkey in 2006 to that in 2007?
Offer a terse response. 0.98. What is the difference between the highest and the second highest Emissions(in percent) in Chile?
Offer a terse response. 1.19. What is the difference between the highest and the second highest Emissions(in percent) in Hungary?
Your answer should be very brief. 0.44. What is the difference between the highest and the second highest Emissions(in percent) of Lithuania?
Provide a succinct answer. 2.04. What is the difference between the highest and the second highest Emissions(in percent) of Turkey?
Your answer should be compact. 0.79. What is the difference between the highest and the lowest Emissions(in percent) in Chile?
Your response must be concise. 2.76. What is the difference between the highest and the lowest Emissions(in percent) of Hungary?
Keep it short and to the point. 4.64. What is the difference between the highest and the lowest Emissions(in percent) in Lithuania?
Your answer should be compact. 4.43. What is the difference between the highest and the lowest Emissions(in percent) in Turkey?
Ensure brevity in your answer.  3.08. 